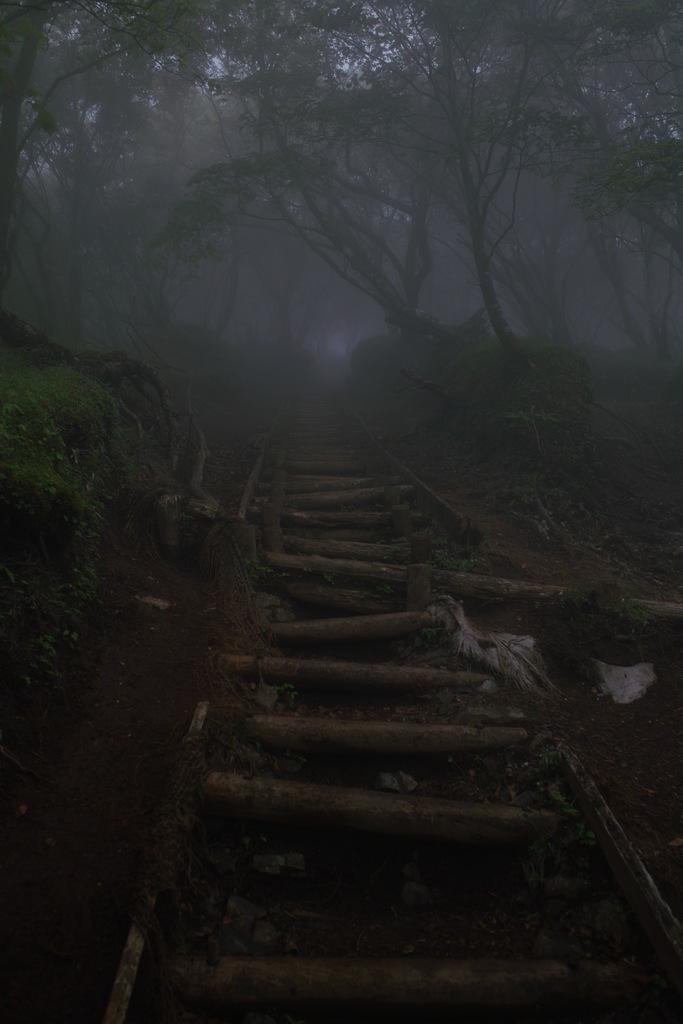Describe this image in one or two sentences. In this image there is grass, plants, trees. 